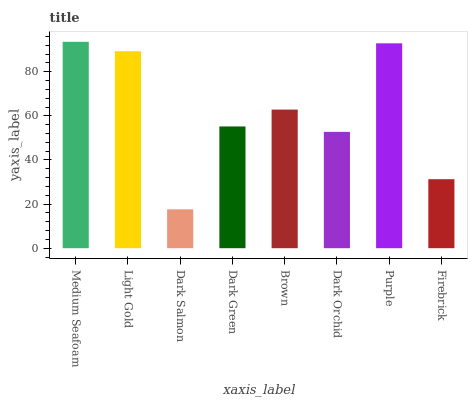Is Light Gold the minimum?
Answer yes or no. No. Is Light Gold the maximum?
Answer yes or no. No. Is Medium Seafoam greater than Light Gold?
Answer yes or no. Yes. Is Light Gold less than Medium Seafoam?
Answer yes or no. Yes. Is Light Gold greater than Medium Seafoam?
Answer yes or no. No. Is Medium Seafoam less than Light Gold?
Answer yes or no. No. Is Brown the high median?
Answer yes or no. Yes. Is Dark Green the low median?
Answer yes or no. Yes. Is Dark Green the high median?
Answer yes or no. No. Is Firebrick the low median?
Answer yes or no. No. 